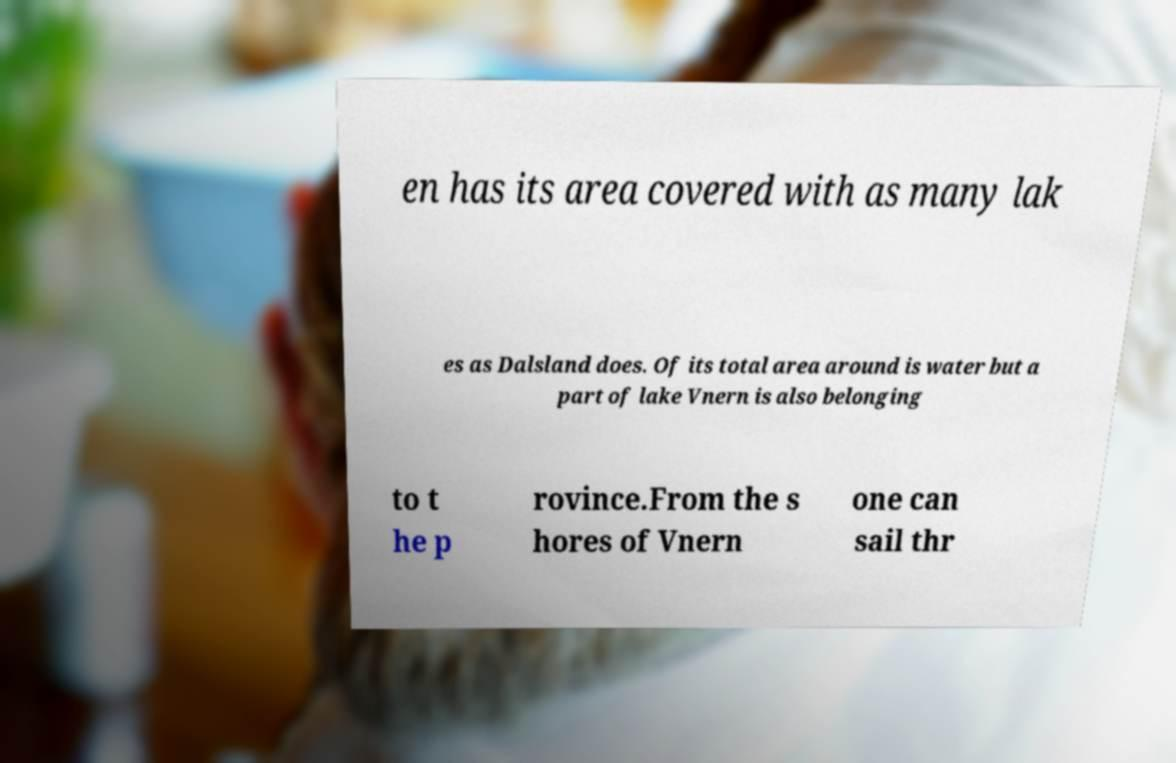There's text embedded in this image that I need extracted. Can you transcribe it verbatim? en has its area covered with as many lak es as Dalsland does. Of its total area around is water but a part of lake Vnern is also belonging to t he p rovince.From the s hores of Vnern one can sail thr 